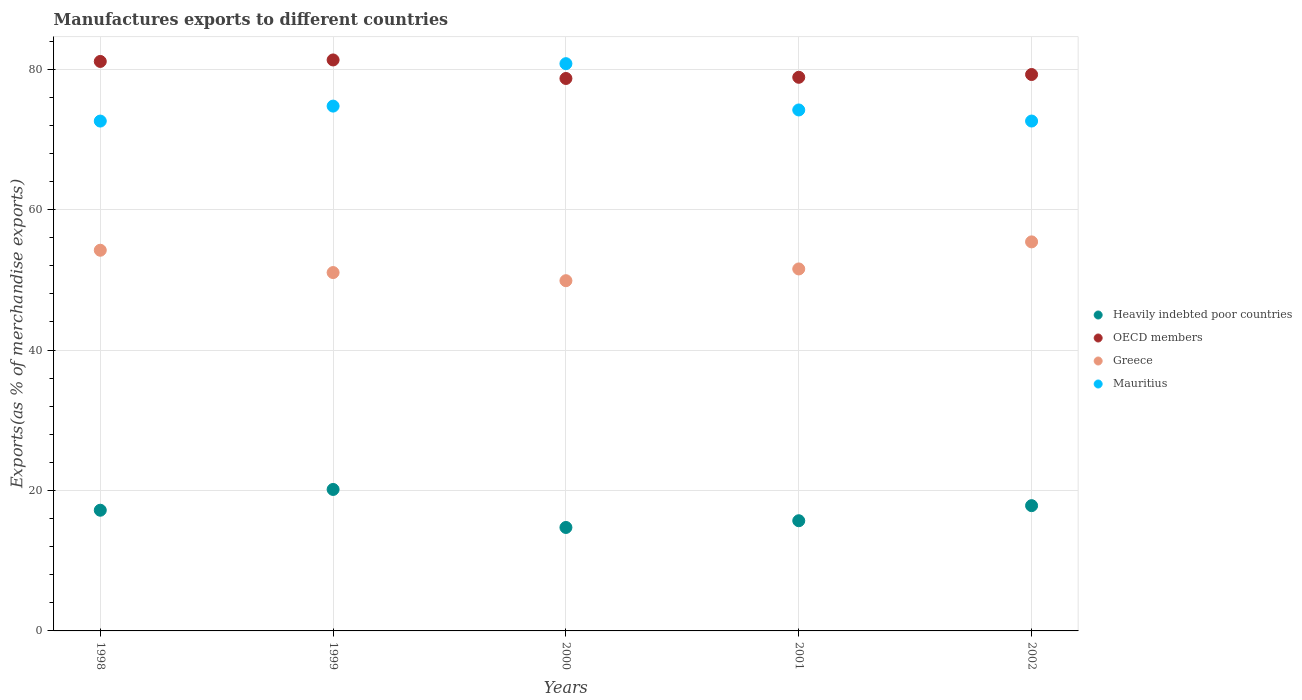How many different coloured dotlines are there?
Provide a short and direct response. 4. What is the percentage of exports to different countries in Mauritius in 2001?
Provide a succinct answer. 74.19. Across all years, what is the maximum percentage of exports to different countries in Greece?
Offer a very short reply. 55.41. Across all years, what is the minimum percentage of exports to different countries in OECD members?
Your answer should be very brief. 78.68. In which year was the percentage of exports to different countries in Greece minimum?
Your answer should be very brief. 2000. What is the total percentage of exports to different countries in Heavily indebted poor countries in the graph?
Provide a succinct answer. 85.6. What is the difference between the percentage of exports to different countries in Greece in 2000 and that in 2001?
Your answer should be compact. -1.67. What is the difference between the percentage of exports to different countries in OECD members in 2002 and the percentage of exports to different countries in Heavily indebted poor countries in 1999?
Offer a very short reply. 59.1. What is the average percentage of exports to different countries in Mauritius per year?
Provide a succinct answer. 74.99. In the year 2001, what is the difference between the percentage of exports to different countries in Heavily indebted poor countries and percentage of exports to different countries in Mauritius?
Keep it short and to the point. -58.5. In how many years, is the percentage of exports to different countries in Mauritius greater than 36 %?
Offer a terse response. 5. What is the ratio of the percentage of exports to different countries in Mauritius in 2001 to that in 2002?
Provide a succinct answer. 1.02. Is the difference between the percentage of exports to different countries in Heavily indebted poor countries in 1998 and 2002 greater than the difference between the percentage of exports to different countries in Mauritius in 1998 and 2002?
Ensure brevity in your answer.  No. What is the difference between the highest and the second highest percentage of exports to different countries in Heavily indebted poor countries?
Make the answer very short. 2.31. What is the difference between the highest and the lowest percentage of exports to different countries in Heavily indebted poor countries?
Make the answer very short. 5.41. Is the sum of the percentage of exports to different countries in OECD members in 1998 and 2000 greater than the maximum percentage of exports to different countries in Heavily indebted poor countries across all years?
Offer a terse response. Yes. Is it the case that in every year, the sum of the percentage of exports to different countries in Mauritius and percentage of exports to different countries in Greece  is greater than the sum of percentage of exports to different countries in Heavily indebted poor countries and percentage of exports to different countries in OECD members?
Offer a terse response. No. Does the percentage of exports to different countries in OECD members monotonically increase over the years?
Your response must be concise. No. Is the percentage of exports to different countries in Heavily indebted poor countries strictly greater than the percentage of exports to different countries in OECD members over the years?
Give a very brief answer. No. How many years are there in the graph?
Offer a terse response. 5. What is the difference between two consecutive major ticks on the Y-axis?
Ensure brevity in your answer.  20. What is the title of the graph?
Your response must be concise. Manufactures exports to different countries. Does "Spain" appear as one of the legend labels in the graph?
Give a very brief answer. No. What is the label or title of the X-axis?
Your answer should be very brief. Years. What is the label or title of the Y-axis?
Your answer should be very brief. Exports(as % of merchandise exports). What is the Exports(as % of merchandise exports) in Heavily indebted poor countries in 1998?
Offer a very short reply. 17.19. What is the Exports(as % of merchandise exports) of OECD members in 1998?
Make the answer very short. 81.1. What is the Exports(as % of merchandise exports) of Greece in 1998?
Offer a terse response. 54.22. What is the Exports(as % of merchandise exports) of Mauritius in 1998?
Keep it short and to the point. 72.61. What is the Exports(as % of merchandise exports) in Heavily indebted poor countries in 1999?
Keep it short and to the point. 20.15. What is the Exports(as % of merchandise exports) in OECD members in 1999?
Give a very brief answer. 81.32. What is the Exports(as % of merchandise exports) in Greece in 1999?
Your answer should be very brief. 51.04. What is the Exports(as % of merchandise exports) in Mauritius in 1999?
Your answer should be very brief. 74.74. What is the Exports(as % of merchandise exports) of Heavily indebted poor countries in 2000?
Make the answer very short. 14.73. What is the Exports(as % of merchandise exports) in OECD members in 2000?
Keep it short and to the point. 78.68. What is the Exports(as % of merchandise exports) in Greece in 2000?
Give a very brief answer. 49.88. What is the Exports(as % of merchandise exports) in Mauritius in 2000?
Offer a very short reply. 80.79. What is the Exports(as % of merchandise exports) in Heavily indebted poor countries in 2001?
Provide a short and direct response. 15.69. What is the Exports(as % of merchandise exports) in OECD members in 2001?
Give a very brief answer. 78.85. What is the Exports(as % of merchandise exports) of Greece in 2001?
Provide a succinct answer. 51.55. What is the Exports(as % of merchandise exports) of Mauritius in 2001?
Offer a very short reply. 74.19. What is the Exports(as % of merchandise exports) of Heavily indebted poor countries in 2002?
Provide a succinct answer. 17.84. What is the Exports(as % of merchandise exports) of OECD members in 2002?
Your answer should be compact. 79.24. What is the Exports(as % of merchandise exports) of Greece in 2002?
Provide a short and direct response. 55.41. What is the Exports(as % of merchandise exports) in Mauritius in 2002?
Keep it short and to the point. 72.61. Across all years, what is the maximum Exports(as % of merchandise exports) of Heavily indebted poor countries?
Your answer should be very brief. 20.15. Across all years, what is the maximum Exports(as % of merchandise exports) in OECD members?
Ensure brevity in your answer.  81.32. Across all years, what is the maximum Exports(as % of merchandise exports) in Greece?
Your response must be concise. 55.41. Across all years, what is the maximum Exports(as % of merchandise exports) in Mauritius?
Provide a succinct answer. 80.79. Across all years, what is the minimum Exports(as % of merchandise exports) in Heavily indebted poor countries?
Give a very brief answer. 14.73. Across all years, what is the minimum Exports(as % of merchandise exports) of OECD members?
Provide a succinct answer. 78.68. Across all years, what is the minimum Exports(as % of merchandise exports) of Greece?
Your answer should be compact. 49.88. Across all years, what is the minimum Exports(as % of merchandise exports) of Mauritius?
Provide a short and direct response. 72.61. What is the total Exports(as % of merchandise exports) in Heavily indebted poor countries in the graph?
Give a very brief answer. 85.6. What is the total Exports(as % of merchandise exports) of OECD members in the graph?
Make the answer very short. 399.19. What is the total Exports(as % of merchandise exports) of Greece in the graph?
Ensure brevity in your answer.  262.09. What is the total Exports(as % of merchandise exports) in Mauritius in the graph?
Offer a terse response. 374.95. What is the difference between the Exports(as % of merchandise exports) in Heavily indebted poor countries in 1998 and that in 1999?
Provide a short and direct response. -2.96. What is the difference between the Exports(as % of merchandise exports) in OECD members in 1998 and that in 1999?
Keep it short and to the point. -0.21. What is the difference between the Exports(as % of merchandise exports) in Greece in 1998 and that in 1999?
Provide a short and direct response. 3.18. What is the difference between the Exports(as % of merchandise exports) in Mauritius in 1998 and that in 1999?
Your answer should be very brief. -2.13. What is the difference between the Exports(as % of merchandise exports) in Heavily indebted poor countries in 1998 and that in 2000?
Your answer should be very brief. 2.46. What is the difference between the Exports(as % of merchandise exports) of OECD members in 1998 and that in 2000?
Give a very brief answer. 2.43. What is the difference between the Exports(as % of merchandise exports) of Greece in 1998 and that in 2000?
Give a very brief answer. 4.34. What is the difference between the Exports(as % of merchandise exports) of Mauritius in 1998 and that in 2000?
Your response must be concise. -8.17. What is the difference between the Exports(as % of merchandise exports) in Heavily indebted poor countries in 1998 and that in 2001?
Your answer should be compact. 1.5. What is the difference between the Exports(as % of merchandise exports) in OECD members in 1998 and that in 2001?
Your answer should be very brief. 2.26. What is the difference between the Exports(as % of merchandise exports) in Greece in 1998 and that in 2001?
Provide a short and direct response. 2.66. What is the difference between the Exports(as % of merchandise exports) of Mauritius in 1998 and that in 2001?
Provide a short and direct response. -1.58. What is the difference between the Exports(as % of merchandise exports) of Heavily indebted poor countries in 1998 and that in 2002?
Your answer should be compact. -0.65. What is the difference between the Exports(as % of merchandise exports) in OECD members in 1998 and that in 2002?
Keep it short and to the point. 1.86. What is the difference between the Exports(as % of merchandise exports) in Greece in 1998 and that in 2002?
Ensure brevity in your answer.  -1.19. What is the difference between the Exports(as % of merchandise exports) in Mauritius in 1998 and that in 2002?
Offer a very short reply. -0. What is the difference between the Exports(as % of merchandise exports) of Heavily indebted poor countries in 1999 and that in 2000?
Ensure brevity in your answer.  5.41. What is the difference between the Exports(as % of merchandise exports) of OECD members in 1999 and that in 2000?
Provide a succinct answer. 2.64. What is the difference between the Exports(as % of merchandise exports) of Greece in 1999 and that in 2000?
Provide a short and direct response. 1.16. What is the difference between the Exports(as % of merchandise exports) in Mauritius in 1999 and that in 2000?
Provide a succinct answer. -6.04. What is the difference between the Exports(as % of merchandise exports) of Heavily indebted poor countries in 1999 and that in 2001?
Make the answer very short. 4.46. What is the difference between the Exports(as % of merchandise exports) of OECD members in 1999 and that in 2001?
Offer a terse response. 2.47. What is the difference between the Exports(as % of merchandise exports) in Greece in 1999 and that in 2001?
Offer a terse response. -0.52. What is the difference between the Exports(as % of merchandise exports) of Mauritius in 1999 and that in 2001?
Keep it short and to the point. 0.55. What is the difference between the Exports(as % of merchandise exports) of Heavily indebted poor countries in 1999 and that in 2002?
Make the answer very short. 2.31. What is the difference between the Exports(as % of merchandise exports) of OECD members in 1999 and that in 2002?
Your response must be concise. 2.07. What is the difference between the Exports(as % of merchandise exports) in Greece in 1999 and that in 2002?
Provide a short and direct response. -4.37. What is the difference between the Exports(as % of merchandise exports) in Mauritius in 1999 and that in 2002?
Ensure brevity in your answer.  2.13. What is the difference between the Exports(as % of merchandise exports) of Heavily indebted poor countries in 2000 and that in 2001?
Your response must be concise. -0.96. What is the difference between the Exports(as % of merchandise exports) of OECD members in 2000 and that in 2001?
Provide a short and direct response. -0.17. What is the difference between the Exports(as % of merchandise exports) in Greece in 2000 and that in 2001?
Your response must be concise. -1.67. What is the difference between the Exports(as % of merchandise exports) of Mauritius in 2000 and that in 2001?
Your answer should be compact. 6.59. What is the difference between the Exports(as % of merchandise exports) in Heavily indebted poor countries in 2000 and that in 2002?
Ensure brevity in your answer.  -3.11. What is the difference between the Exports(as % of merchandise exports) in OECD members in 2000 and that in 2002?
Ensure brevity in your answer.  -0.57. What is the difference between the Exports(as % of merchandise exports) in Greece in 2000 and that in 2002?
Offer a terse response. -5.53. What is the difference between the Exports(as % of merchandise exports) of Mauritius in 2000 and that in 2002?
Offer a terse response. 8.17. What is the difference between the Exports(as % of merchandise exports) of Heavily indebted poor countries in 2001 and that in 2002?
Offer a terse response. -2.15. What is the difference between the Exports(as % of merchandise exports) in OECD members in 2001 and that in 2002?
Your answer should be compact. -0.4. What is the difference between the Exports(as % of merchandise exports) of Greece in 2001 and that in 2002?
Give a very brief answer. -3.85. What is the difference between the Exports(as % of merchandise exports) of Mauritius in 2001 and that in 2002?
Ensure brevity in your answer.  1.58. What is the difference between the Exports(as % of merchandise exports) in Heavily indebted poor countries in 1998 and the Exports(as % of merchandise exports) in OECD members in 1999?
Provide a short and direct response. -64.13. What is the difference between the Exports(as % of merchandise exports) of Heavily indebted poor countries in 1998 and the Exports(as % of merchandise exports) of Greece in 1999?
Provide a short and direct response. -33.85. What is the difference between the Exports(as % of merchandise exports) in Heavily indebted poor countries in 1998 and the Exports(as % of merchandise exports) in Mauritius in 1999?
Offer a terse response. -57.55. What is the difference between the Exports(as % of merchandise exports) in OECD members in 1998 and the Exports(as % of merchandise exports) in Greece in 1999?
Make the answer very short. 30.07. What is the difference between the Exports(as % of merchandise exports) in OECD members in 1998 and the Exports(as % of merchandise exports) in Mauritius in 1999?
Give a very brief answer. 6.36. What is the difference between the Exports(as % of merchandise exports) in Greece in 1998 and the Exports(as % of merchandise exports) in Mauritius in 1999?
Provide a short and direct response. -20.53. What is the difference between the Exports(as % of merchandise exports) of Heavily indebted poor countries in 1998 and the Exports(as % of merchandise exports) of OECD members in 2000?
Ensure brevity in your answer.  -61.49. What is the difference between the Exports(as % of merchandise exports) of Heavily indebted poor countries in 1998 and the Exports(as % of merchandise exports) of Greece in 2000?
Ensure brevity in your answer.  -32.69. What is the difference between the Exports(as % of merchandise exports) in Heavily indebted poor countries in 1998 and the Exports(as % of merchandise exports) in Mauritius in 2000?
Your answer should be compact. -63.6. What is the difference between the Exports(as % of merchandise exports) in OECD members in 1998 and the Exports(as % of merchandise exports) in Greece in 2000?
Keep it short and to the point. 31.23. What is the difference between the Exports(as % of merchandise exports) of OECD members in 1998 and the Exports(as % of merchandise exports) of Mauritius in 2000?
Make the answer very short. 0.32. What is the difference between the Exports(as % of merchandise exports) in Greece in 1998 and the Exports(as % of merchandise exports) in Mauritius in 2000?
Offer a very short reply. -26.57. What is the difference between the Exports(as % of merchandise exports) in Heavily indebted poor countries in 1998 and the Exports(as % of merchandise exports) in OECD members in 2001?
Provide a short and direct response. -61.66. What is the difference between the Exports(as % of merchandise exports) of Heavily indebted poor countries in 1998 and the Exports(as % of merchandise exports) of Greece in 2001?
Ensure brevity in your answer.  -34.36. What is the difference between the Exports(as % of merchandise exports) in Heavily indebted poor countries in 1998 and the Exports(as % of merchandise exports) in Mauritius in 2001?
Offer a terse response. -57. What is the difference between the Exports(as % of merchandise exports) in OECD members in 1998 and the Exports(as % of merchandise exports) in Greece in 2001?
Provide a short and direct response. 29.55. What is the difference between the Exports(as % of merchandise exports) in OECD members in 1998 and the Exports(as % of merchandise exports) in Mauritius in 2001?
Ensure brevity in your answer.  6.91. What is the difference between the Exports(as % of merchandise exports) of Greece in 1998 and the Exports(as % of merchandise exports) of Mauritius in 2001?
Offer a terse response. -19.98. What is the difference between the Exports(as % of merchandise exports) in Heavily indebted poor countries in 1998 and the Exports(as % of merchandise exports) in OECD members in 2002?
Your answer should be compact. -62.05. What is the difference between the Exports(as % of merchandise exports) in Heavily indebted poor countries in 1998 and the Exports(as % of merchandise exports) in Greece in 2002?
Your answer should be very brief. -38.22. What is the difference between the Exports(as % of merchandise exports) in Heavily indebted poor countries in 1998 and the Exports(as % of merchandise exports) in Mauritius in 2002?
Provide a short and direct response. -55.43. What is the difference between the Exports(as % of merchandise exports) in OECD members in 1998 and the Exports(as % of merchandise exports) in Greece in 2002?
Your answer should be compact. 25.7. What is the difference between the Exports(as % of merchandise exports) of OECD members in 1998 and the Exports(as % of merchandise exports) of Mauritius in 2002?
Keep it short and to the point. 8.49. What is the difference between the Exports(as % of merchandise exports) in Greece in 1998 and the Exports(as % of merchandise exports) in Mauritius in 2002?
Make the answer very short. -18.4. What is the difference between the Exports(as % of merchandise exports) of Heavily indebted poor countries in 1999 and the Exports(as % of merchandise exports) of OECD members in 2000?
Your answer should be compact. -58.53. What is the difference between the Exports(as % of merchandise exports) in Heavily indebted poor countries in 1999 and the Exports(as % of merchandise exports) in Greece in 2000?
Ensure brevity in your answer.  -29.73. What is the difference between the Exports(as % of merchandise exports) in Heavily indebted poor countries in 1999 and the Exports(as % of merchandise exports) in Mauritius in 2000?
Ensure brevity in your answer.  -60.64. What is the difference between the Exports(as % of merchandise exports) of OECD members in 1999 and the Exports(as % of merchandise exports) of Greece in 2000?
Provide a short and direct response. 31.44. What is the difference between the Exports(as % of merchandise exports) of OECD members in 1999 and the Exports(as % of merchandise exports) of Mauritius in 2000?
Your answer should be very brief. 0.53. What is the difference between the Exports(as % of merchandise exports) in Greece in 1999 and the Exports(as % of merchandise exports) in Mauritius in 2000?
Make the answer very short. -29.75. What is the difference between the Exports(as % of merchandise exports) in Heavily indebted poor countries in 1999 and the Exports(as % of merchandise exports) in OECD members in 2001?
Offer a terse response. -58.7. What is the difference between the Exports(as % of merchandise exports) of Heavily indebted poor countries in 1999 and the Exports(as % of merchandise exports) of Greece in 2001?
Make the answer very short. -31.4. What is the difference between the Exports(as % of merchandise exports) of Heavily indebted poor countries in 1999 and the Exports(as % of merchandise exports) of Mauritius in 2001?
Offer a terse response. -54.05. What is the difference between the Exports(as % of merchandise exports) in OECD members in 1999 and the Exports(as % of merchandise exports) in Greece in 2001?
Give a very brief answer. 29.76. What is the difference between the Exports(as % of merchandise exports) of OECD members in 1999 and the Exports(as % of merchandise exports) of Mauritius in 2001?
Your response must be concise. 7.12. What is the difference between the Exports(as % of merchandise exports) in Greece in 1999 and the Exports(as % of merchandise exports) in Mauritius in 2001?
Provide a short and direct response. -23.16. What is the difference between the Exports(as % of merchandise exports) in Heavily indebted poor countries in 1999 and the Exports(as % of merchandise exports) in OECD members in 2002?
Provide a short and direct response. -59.1. What is the difference between the Exports(as % of merchandise exports) of Heavily indebted poor countries in 1999 and the Exports(as % of merchandise exports) of Greece in 2002?
Your response must be concise. -35.26. What is the difference between the Exports(as % of merchandise exports) in Heavily indebted poor countries in 1999 and the Exports(as % of merchandise exports) in Mauritius in 2002?
Your answer should be very brief. -52.47. What is the difference between the Exports(as % of merchandise exports) in OECD members in 1999 and the Exports(as % of merchandise exports) in Greece in 2002?
Provide a short and direct response. 25.91. What is the difference between the Exports(as % of merchandise exports) of OECD members in 1999 and the Exports(as % of merchandise exports) of Mauritius in 2002?
Give a very brief answer. 8.7. What is the difference between the Exports(as % of merchandise exports) in Greece in 1999 and the Exports(as % of merchandise exports) in Mauritius in 2002?
Provide a succinct answer. -21.58. What is the difference between the Exports(as % of merchandise exports) of Heavily indebted poor countries in 2000 and the Exports(as % of merchandise exports) of OECD members in 2001?
Keep it short and to the point. -64.11. What is the difference between the Exports(as % of merchandise exports) of Heavily indebted poor countries in 2000 and the Exports(as % of merchandise exports) of Greece in 2001?
Make the answer very short. -36.82. What is the difference between the Exports(as % of merchandise exports) of Heavily indebted poor countries in 2000 and the Exports(as % of merchandise exports) of Mauritius in 2001?
Your response must be concise. -59.46. What is the difference between the Exports(as % of merchandise exports) in OECD members in 2000 and the Exports(as % of merchandise exports) in Greece in 2001?
Ensure brevity in your answer.  27.13. What is the difference between the Exports(as % of merchandise exports) in OECD members in 2000 and the Exports(as % of merchandise exports) in Mauritius in 2001?
Make the answer very short. 4.49. What is the difference between the Exports(as % of merchandise exports) in Greece in 2000 and the Exports(as % of merchandise exports) in Mauritius in 2001?
Offer a very short reply. -24.31. What is the difference between the Exports(as % of merchandise exports) in Heavily indebted poor countries in 2000 and the Exports(as % of merchandise exports) in OECD members in 2002?
Offer a very short reply. -64.51. What is the difference between the Exports(as % of merchandise exports) of Heavily indebted poor countries in 2000 and the Exports(as % of merchandise exports) of Greece in 2002?
Provide a succinct answer. -40.67. What is the difference between the Exports(as % of merchandise exports) in Heavily indebted poor countries in 2000 and the Exports(as % of merchandise exports) in Mauritius in 2002?
Your answer should be compact. -57.88. What is the difference between the Exports(as % of merchandise exports) in OECD members in 2000 and the Exports(as % of merchandise exports) in Greece in 2002?
Your response must be concise. 23.27. What is the difference between the Exports(as % of merchandise exports) in OECD members in 2000 and the Exports(as % of merchandise exports) in Mauritius in 2002?
Ensure brevity in your answer.  6.06. What is the difference between the Exports(as % of merchandise exports) of Greece in 2000 and the Exports(as % of merchandise exports) of Mauritius in 2002?
Your response must be concise. -22.74. What is the difference between the Exports(as % of merchandise exports) in Heavily indebted poor countries in 2001 and the Exports(as % of merchandise exports) in OECD members in 2002?
Your answer should be very brief. -63.55. What is the difference between the Exports(as % of merchandise exports) in Heavily indebted poor countries in 2001 and the Exports(as % of merchandise exports) in Greece in 2002?
Provide a succinct answer. -39.71. What is the difference between the Exports(as % of merchandise exports) in Heavily indebted poor countries in 2001 and the Exports(as % of merchandise exports) in Mauritius in 2002?
Your response must be concise. -56.92. What is the difference between the Exports(as % of merchandise exports) in OECD members in 2001 and the Exports(as % of merchandise exports) in Greece in 2002?
Offer a terse response. 23.44. What is the difference between the Exports(as % of merchandise exports) of OECD members in 2001 and the Exports(as % of merchandise exports) of Mauritius in 2002?
Offer a terse response. 6.23. What is the difference between the Exports(as % of merchandise exports) of Greece in 2001 and the Exports(as % of merchandise exports) of Mauritius in 2002?
Provide a succinct answer. -21.06. What is the average Exports(as % of merchandise exports) in Heavily indebted poor countries per year?
Your answer should be very brief. 17.12. What is the average Exports(as % of merchandise exports) of OECD members per year?
Your answer should be compact. 79.84. What is the average Exports(as % of merchandise exports) in Greece per year?
Ensure brevity in your answer.  52.42. What is the average Exports(as % of merchandise exports) of Mauritius per year?
Your answer should be very brief. 74.99. In the year 1998, what is the difference between the Exports(as % of merchandise exports) in Heavily indebted poor countries and Exports(as % of merchandise exports) in OECD members?
Keep it short and to the point. -63.92. In the year 1998, what is the difference between the Exports(as % of merchandise exports) of Heavily indebted poor countries and Exports(as % of merchandise exports) of Greece?
Your answer should be compact. -37.03. In the year 1998, what is the difference between the Exports(as % of merchandise exports) of Heavily indebted poor countries and Exports(as % of merchandise exports) of Mauritius?
Your response must be concise. -55.42. In the year 1998, what is the difference between the Exports(as % of merchandise exports) in OECD members and Exports(as % of merchandise exports) in Greece?
Your answer should be compact. 26.89. In the year 1998, what is the difference between the Exports(as % of merchandise exports) in OECD members and Exports(as % of merchandise exports) in Mauritius?
Make the answer very short. 8.49. In the year 1998, what is the difference between the Exports(as % of merchandise exports) in Greece and Exports(as % of merchandise exports) in Mauritius?
Your answer should be compact. -18.4. In the year 1999, what is the difference between the Exports(as % of merchandise exports) in Heavily indebted poor countries and Exports(as % of merchandise exports) in OECD members?
Give a very brief answer. -61.17. In the year 1999, what is the difference between the Exports(as % of merchandise exports) of Heavily indebted poor countries and Exports(as % of merchandise exports) of Greece?
Your response must be concise. -30.89. In the year 1999, what is the difference between the Exports(as % of merchandise exports) in Heavily indebted poor countries and Exports(as % of merchandise exports) in Mauritius?
Ensure brevity in your answer.  -54.6. In the year 1999, what is the difference between the Exports(as % of merchandise exports) in OECD members and Exports(as % of merchandise exports) in Greece?
Your answer should be very brief. 30.28. In the year 1999, what is the difference between the Exports(as % of merchandise exports) of OECD members and Exports(as % of merchandise exports) of Mauritius?
Keep it short and to the point. 6.57. In the year 1999, what is the difference between the Exports(as % of merchandise exports) in Greece and Exports(as % of merchandise exports) in Mauritius?
Offer a very short reply. -23.71. In the year 2000, what is the difference between the Exports(as % of merchandise exports) in Heavily indebted poor countries and Exports(as % of merchandise exports) in OECD members?
Your response must be concise. -63.94. In the year 2000, what is the difference between the Exports(as % of merchandise exports) in Heavily indebted poor countries and Exports(as % of merchandise exports) in Greece?
Provide a succinct answer. -35.15. In the year 2000, what is the difference between the Exports(as % of merchandise exports) in Heavily indebted poor countries and Exports(as % of merchandise exports) in Mauritius?
Your answer should be compact. -66.05. In the year 2000, what is the difference between the Exports(as % of merchandise exports) of OECD members and Exports(as % of merchandise exports) of Greece?
Offer a terse response. 28.8. In the year 2000, what is the difference between the Exports(as % of merchandise exports) in OECD members and Exports(as % of merchandise exports) in Mauritius?
Ensure brevity in your answer.  -2.11. In the year 2000, what is the difference between the Exports(as % of merchandise exports) in Greece and Exports(as % of merchandise exports) in Mauritius?
Offer a terse response. -30.91. In the year 2001, what is the difference between the Exports(as % of merchandise exports) in Heavily indebted poor countries and Exports(as % of merchandise exports) in OECD members?
Offer a terse response. -63.15. In the year 2001, what is the difference between the Exports(as % of merchandise exports) of Heavily indebted poor countries and Exports(as % of merchandise exports) of Greece?
Give a very brief answer. -35.86. In the year 2001, what is the difference between the Exports(as % of merchandise exports) of Heavily indebted poor countries and Exports(as % of merchandise exports) of Mauritius?
Provide a succinct answer. -58.5. In the year 2001, what is the difference between the Exports(as % of merchandise exports) in OECD members and Exports(as % of merchandise exports) in Greece?
Your answer should be very brief. 27.29. In the year 2001, what is the difference between the Exports(as % of merchandise exports) in OECD members and Exports(as % of merchandise exports) in Mauritius?
Offer a terse response. 4.65. In the year 2001, what is the difference between the Exports(as % of merchandise exports) of Greece and Exports(as % of merchandise exports) of Mauritius?
Provide a succinct answer. -22.64. In the year 2002, what is the difference between the Exports(as % of merchandise exports) of Heavily indebted poor countries and Exports(as % of merchandise exports) of OECD members?
Your answer should be very brief. -61.4. In the year 2002, what is the difference between the Exports(as % of merchandise exports) of Heavily indebted poor countries and Exports(as % of merchandise exports) of Greece?
Provide a short and direct response. -37.57. In the year 2002, what is the difference between the Exports(as % of merchandise exports) in Heavily indebted poor countries and Exports(as % of merchandise exports) in Mauritius?
Your response must be concise. -54.77. In the year 2002, what is the difference between the Exports(as % of merchandise exports) in OECD members and Exports(as % of merchandise exports) in Greece?
Your response must be concise. 23.84. In the year 2002, what is the difference between the Exports(as % of merchandise exports) of OECD members and Exports(as % of merchandise exports) of Mauritius?
Your response must be concise. 6.63. In the year 2002, what is the difference between the Exports(as % of merchandise exports) of Greece and Exports(as % of merchandise exports) of Mauritius?
Your answer should be very brief. -17.21. What is the ratio of the Exports(as % of merchandise exports) in Heavily indebted poor countries in 1998 to that in 1999?
Make the answer very short. 0.85. What is the ratio of the Exports(as % of merchandise exports) of Greece in 1998 to that in 1999?
Offer a terse response. 1.06. What is the ratio of the Exports(as % of merchandise exports) in Mauritius in 1998 to that in 1999?
Ensure brevity in your answer.  0.97. What is the ratio of the Exports(as % of merchandise exports) in Heavily indebted poor countries in 1998 to that in 2000?
Keep it short and to the point. 1.17. What is the ratio of the Exports(as % of merchandise exports) in OECD members in 1998 to that in 2000?
Provide a succinct answer. 1.03. What is the ratio of the Exports(as % of merchandise exports) of Greece in 1998 to that in 2000?
Make the answer very short. 1.09. What is the ratio of the Exports(as % of merchandise exports) of Mauritius in 1998 to that in 2000?
Offer a terse response. 0.9. What is the ratio of the Exports(as % of merchandise exports) of Heavily indebted poor countries in 1998 to that in 2001?
Your response must be concise. 1.1. What is the ratio of the Exports(as % of merchandise exports) of OECD members in 1998 to that in 2001?
Ensure brevity in your answer.  1.03. What is the ratio of the Exports(as % of merchandise exports) in Greece in 1998 to that in 2001?
Offer a terse response. 1.05. What is the ratio of the Exports(as % of merchandise exports) in Mauritius in 1998 to that in 2001?
Give a very brief answer. 0.98. What is the ratio of the Exports(as % of merchandise exports) in Heavily indebted poor countries in 1998 to that in 2002?
Your response must be concise. 0.96. What is the ratio of the Exports(as % of merchandise exports) of OECD members in 1998 to that in 2002?
Your answer should be compact. 1.02. What is the ratio of the Exports(as % of merchandise exports) in Greece in 1998 to that in 2002?
Keep it short and to the point. 0.98. What is the ratio of the Exports(as % of merchandise exports) of Heavily indebted poor countries in 1999 to that in 2000?
Offer a very short reply. 1.37. What is the ratio of the Exports(as % of merchandise exports) of OECD members in 1999 to that in 2000?
Offer a very short reply. 1.03. What is the ratio of the Exports(as % of merchandise exports) of Greece in 1999 to that in 2000?
Provide a succinct answer. 1.02. What is the ratio of the Exports(as % of merchandise exports) in Mauritius in 1999 to that in 2000?
Offer a very short reply. 0.93. What is the ratio of the Exports(as % of merchandise exports) in Heavily indebted poor countries in 1999 to that in 2001?
Provide a short and direct response. 1.28. What is the ratio of the Exports(as % of merchandise exports) of OECD members in 1999 to that in 2001?
Offer a very short reply. 1.03. What is the ratio of the Exports(as % of merchandise exports) of Mauritius in 1999 to that in 2001?
Provide a short and direct response. 1.01. What is the ratio of the Exports(as % of merchandise exports) in Heavily indebted poor countries in 1999 to that in 2002?
Make the answer very short. 1.13. What is the ratio of the Exports(as % of merchandise exports) in OECD members in 1999 to that in 2002?
Provide a succinct answer. 1.03. What is the ratio of the Exports(as % of merchandise exports) of Greece in 1999 to that in 2002?
Keep it short and to the point. 0.92. What is the ratio of the Exports(as % of merchandise exports) of Mauritius in 1999 to that in 2002?
Make the answer very short. 1.03. What is the ratio of the Exports(as % of merchandise exports) of Heavily indebted poor countries in 2000 to that in 2001?
Offer a terse response. 0.94. What is the ratio of the Exports(as % of merchandise exports) in OECD members in 2000 to that in 2001?
Offer a very short reply. 1. What is the ratio of the Exports(as % of merchandise exports) in Greece in 2000 to that in 2001?
Ensure brevity in your answer.  0.97. What is the ratio of the Exports(as % of merchandise exports) in Mauritius in 2000 to that in 2001?
Your answer should be very brief. 1.09. What is the ratio of the Exports(as % of merchandise exports) of Heavily indebted poor countries in 2000 to that in 2002?
Give a very brief answer. 0.83. What is the ratio of the Exports(as % of merchandise exports) of Greece in 2000 to that in 2002?
Your answer should be very brief. 0.9. What is the ratio of the Exports(as % of merchandise exports) of Mauritius in 2000 to that in 2002?
Offer a terse response. 1.11. What is the ratio of the Exports(as % of merchandise exports) of Heavily indebted poor countries in 2001 to that in 2002?
Provide a succinct answer. 0.88. What is the ratio of the Exports(as % of merchandise exports) of OECD members in 2001 to that in 2002?
Give a very brief answer. 0.99. What is the ratio of the Exports(as % of merchandise exports) of Greece in 2001 to that in 2002?
Provide a succinct answer. 0.93. What is the ratio of the Exports(as % of merchandise exports) of Mauritius in 2001 to that in 2002?
Offer a terse response. 1.02. What is the difference between the highest and the second highest Exports(as % of merchandise exports) in Heavily indebted poor countries?
Make the answer very short. 2.31. What is the difference between the highest and the second highest Exports(as % of merchandise exports) of OECD members?
Your response must be concise. 0.21. What is the difference between the highest and the second highest Exports(as % of merchandise exports) in Greece?
Your answer should be compact. 1.19. What is the difference between the highest and the second highest Exports(as % of merchandise exports) of Mauritius?
Offer a terse response. 6.04. What is the difference between the highest and the lowest Exports(as % of merchandise exports) in Heavily indebted poor countries?
Keep it short and to the point. 5.41. What is the difference between the highest and the lowest Exports(as % of merchandise exports) of OECD members?
Make the answer very short. 2.64. What is the difference between the highest and the lowest Exports(as % of merchandise exports) in Greece?
Provide a succinct answer. 5.53. What is the difference between the highest and the lowest Exports(as % of merchandise exports) in Mauritius?
Offer a very short reply. 8.17. 